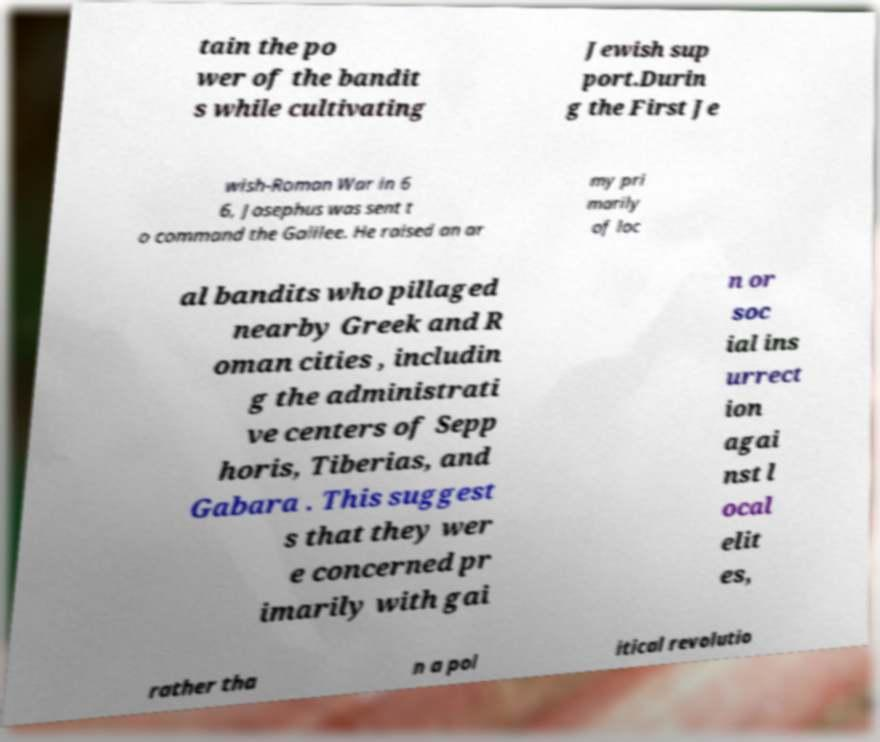Can you accurately transcribe the text from the provided image for me? tain the po wer of the bandit s while cultivating Jewish sup port.Durin g the First Je wish-Roman War in 6 6, Josephus was sent t o command the Galilee. He raised an ar my pri marily of loc al bandits who pillaged nearby Greek and R oman cities , includin g the administrati ve centers of Sepp horis, Tiberias, and Gabara . This suggest s that they wer e concerned pr imarily with gai n or soc ial ins urrect ion agai nst l ocal elit es, rather tha n a pol itical revolutio 